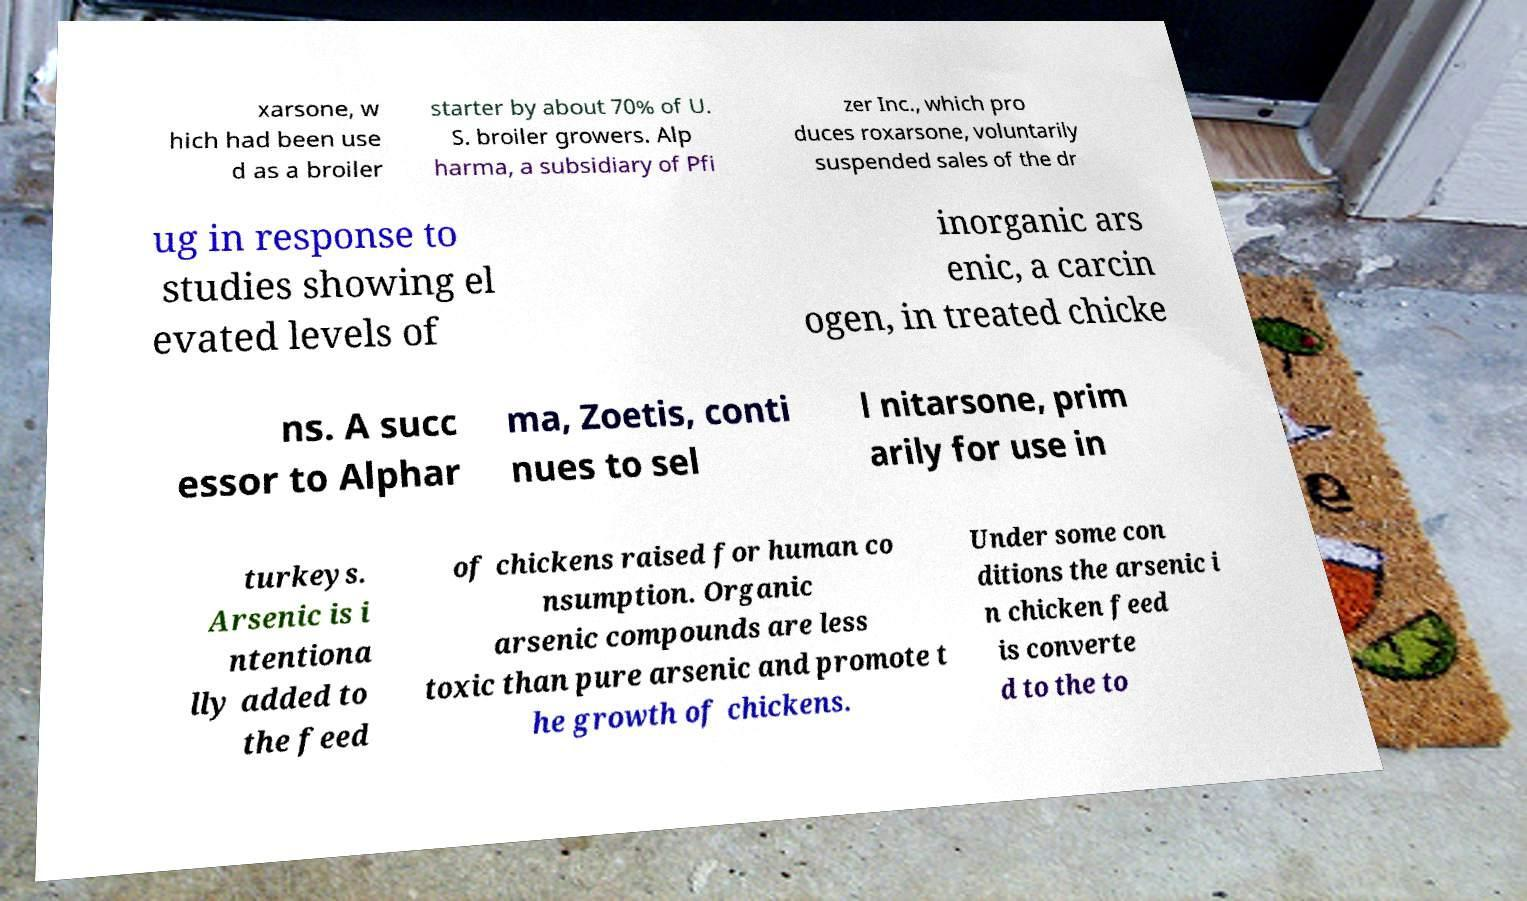What messages or text are displayed in this image? I need them in a readable, typed format. xarsone, w hich had been use d as a broiler starter by about 70% of U. S. broiler growers. Alp harma, a subsidiary of Pfi zer Inc., which pro duces roxarsone, voluntarily suspended sales of the dr ug in response to studies showing el evated levels of inorganic ars enic, a carcin ogen, in treated chicke ns. A succ essor to Alphar ma, Zoetis, conti nues to sel l nitarsone, prim arily for use in turkeys. Arsenic is i ntentiona lly added to the feed of chickens raised for human co nsumption. Organic arsenic compounds are less toxic than pure arsenic and promote t he growth of chickens. Under some con ditions the arsenic i n chicken feed is converte d to the to 